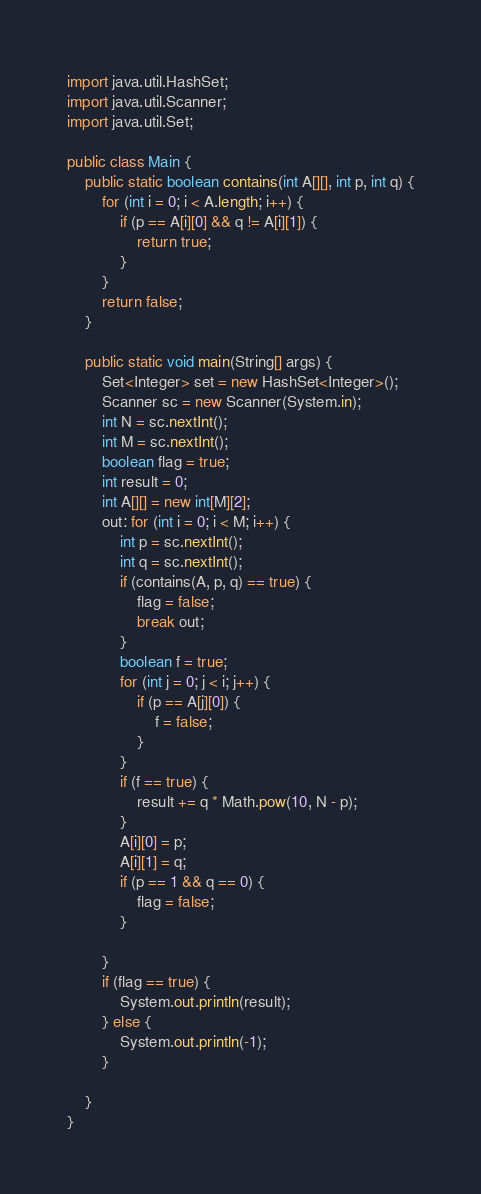<code> <loc_0><loc_0><loc_500><loc_500><_Java_>import java.util.HashSet;
import java.util.Scanner;
import java.util.Set;

public class Main {
	public static boolean contains(int A[][], int p, int q) {
		for (int i = 0; i < A.length; i++) {
			if (p == A[i][0] && q != A[i][1]) {
				return true;
			}
		}
		return false;
	}

	public static void main(String[] args) {
		Set<Integer> set = new HashSet<Integer>();
		Scanner sc = new Scanner(System.in);
		int N = sc.nextInt();
		int M = sc.nextInt();
		boolean flag = true;
		int result = 0;
		int A[][] = new int[M][2];
		out: for (int i = 0; i < M; i++) {
			int p = sc.nextInt();
			int q = sc.nextInt();
			if (contains(A, p, q) == true) {
				flag = false;
				break out;
			}
			boolean f = true;
			for (int j = 0; j < i; j++) {
				if (p == A[j][0]) {
					f = false;
				}
			}
			if (f == true) {
				result += q * Math.pow(10, N - p);
			}
			A[i][0] = p;
			A[i][1] = q;
			if (p == 1 && q == 0) {
				flag = false;
			}

		}
		if (flag == true) {
			System.out.println(result);
		} else {
			System.out.println(-1);
		}

	}
}
</code> 